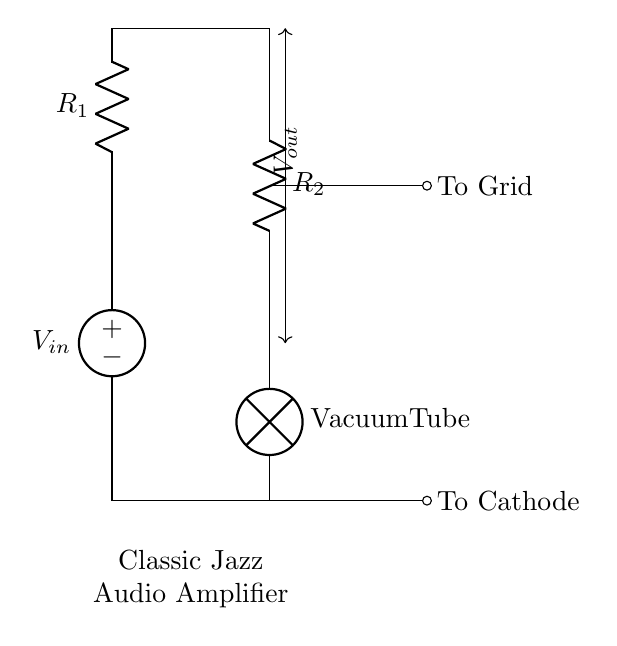What is the voltage source in this circuit? The voltage source in the circuit is represented as V_in, shown at the top of the diagram. It provides the input voltage to the circuit.
Answer: V_in What are the resistors used in this voltage divider? The two resistors in the circuit are labeled R_1 and R_2. R_1 is positioned above R_2 in the diagram.
Answer: R_1 and R_2 What is V_out in this circuit? V_out is the voltage that appears across R_2 in the voltage divider configuration, which is indicated by the arrows pointing vertically between R_1 and R_2.
Answer: V_out What component follows R_2 in the circuit? The component that follows R_2 is a vacuum tube, indicated as "Vacuum Tube" in the diagram. This component is typically used in audio amplification.
Answer: Vacuum Tube How does the output voltage relate to the input voltage? The output voltage (V_out) is a fraction of the input voltage (V_in) based on the resistor values (R_1 and R_2). This is the principle of a voltage divider, where V_out = V_in * (R_2 / (R_1 + R_2)).
Answer: V_out is a fraction of V_in What is the main purpose of the voltage divider in this amplifier circuit? The main purpose of the voltage divider is to provide the correct biasing voltage to the grid of the vacuum tube, which is essential for its proper operation in the amplifier.
Answer: Biasing voltage for the vacuum tube What does "To Grid" indicate in this circuit? "To Grid" indicates the connection point where the output voltage (V_out) is applied to the grid terminal of the vacuum tube, affecting its operation and amplification characteristics.
Answer: Connection to the grid 